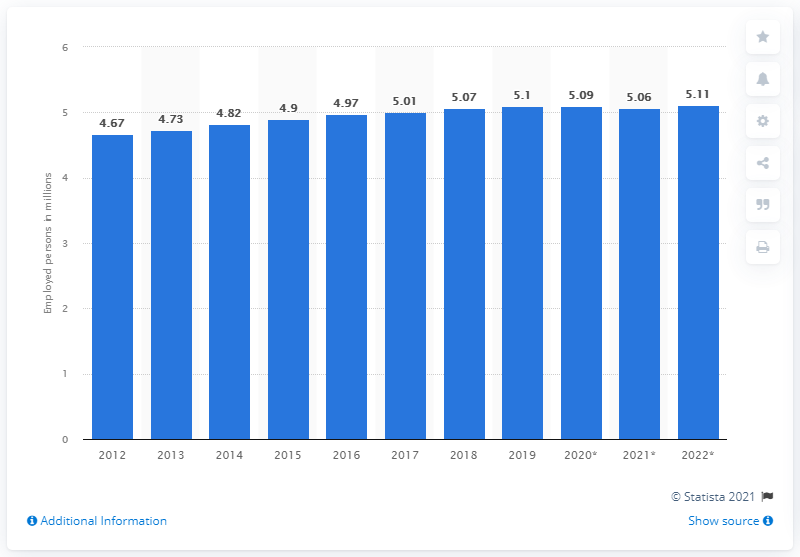Indicate a few pertinent items in this graphic. In 2019, there were 5.11 million gainfully employed persons in Switzerland. 